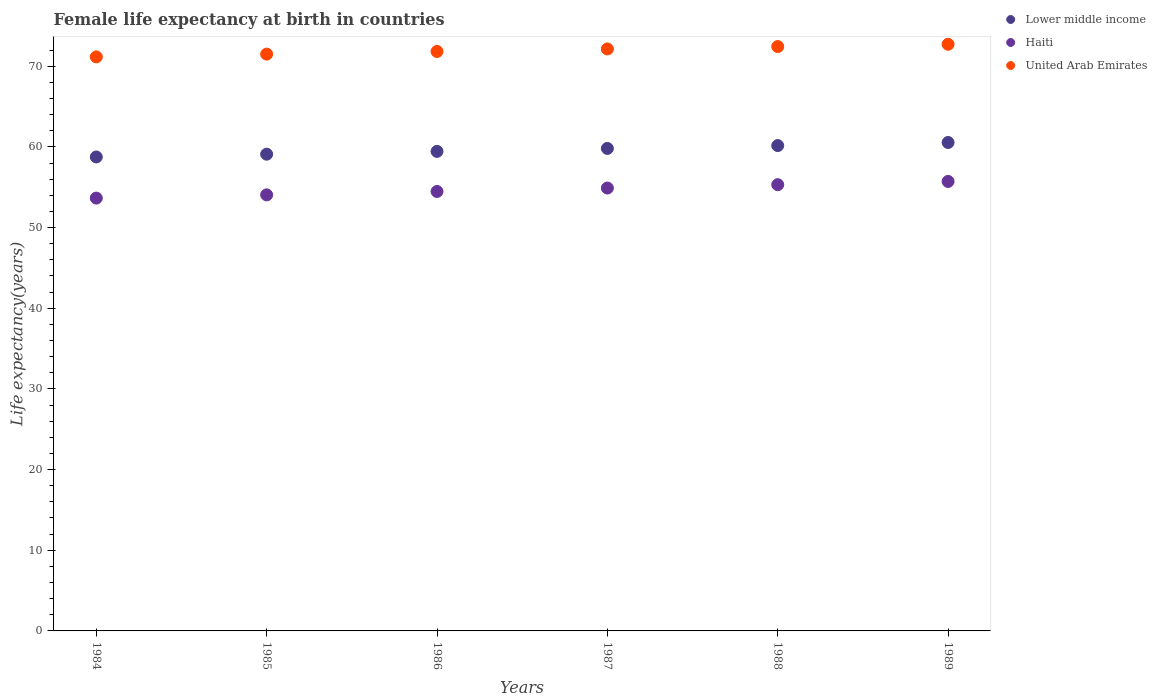What is the female life expectancy at birth in Haiti in 1987?
Provide a short and direct response. 54.9. Across all years, what is the maximum female life expectancy at birth in Lower middle income?
Your answer should be very brief. 60.55. Across all years, what is the minimum female life expectancy at birth in United Arab Emirates?
Make the answer very short. 71.16. In which year was the female life expectancy at birth in Lower middle income maximum?
Offer a very short reply. 1989. In which year was the female life expectancy at birth in Lower middle income minimum?
Provide a succinct answer. 1984. What is the total female life expectancy at birth in United Arab Emirates in the graph?
Offer a terse response. 431.77. What is the difference between the female life expectancy at birth in United Arab Emirates in 1984 and that in 1987?
Provide a succinct answer. -0.98. What is the difference between the female life expectancy at birth in Lower middle income in 1985 and the female life expectancy at birth in Haiti in 1988?
Keep it short and to the point. 3.78. What is the average female life expectancy at birth in Haiti per year?
Provide a short and direct response. 54.68. In the year 1984, what is the difference between the female life expectancy at birth in Lower middle income and female life expectancy at birth in United Arab Emirates?
Provide a succinct answer. -12.4. In how many years, is the female life expectancy at birth in Lower middle income greater than 52 years?
Provide a short and direct response. 6. What is the ratio of the female life expectancy at birth in Lower middle income in 1988 to that in 1989?
Provide a short and direct response. 0.99. Is the difference between the female life expectancy at birth in Lower middle income in 1984 and 1986 greater than the difference between the female life expectancy at birth in United Arab Emirates in 1984 and 1986?
Your response must be concise. No. What is the difference between the highest and the second highest female life expectancy at birth in Lower middle income?
Make the answer very short. 0.38. What is the difference between the highest and the lowest female life expectancy at birth in Lower middle income?
Provide a succinct answer. 1.8. Is it the case that in every year, the sum of the female life expectancy at birth in Lower middle income and female life expectancy at birth in Haiti  is greater than the female life expectancy at birth in United Arab Emirates?
Offer a very short reply. Yes. Does the female life expectancy at birth in Lower middle income monotonically increase over the years?
Make the answer very short. Yes. Are the values on the major ticks of Y-axis written in scientific E-notation?
Provide a succinct answer. No. Does the graph contain any zero values?
Offer a terse response. No. Does the graph contain grids?
Offer a terse response. No. What is the title of the graph?
Provide a short and direct response. Female life expectancy at birth in countries. Does "Middle East & North Africa (developing only)" appear as one of the legend labels in the graph?
Your response must be concise. No. What is the label or title of the Y-axis?
Make the answer very short. Life expectancy(years). What is the Life expectancy(years) in Lower middle income in 1984?
Your answer should be very brief. 58.75. What is the Life expectancy(years) in Haiti in 1984?
Provide a short and direct response. 53.65. What is the Life expectancy(years) in United Arab Emirates in 1984?
Your response must be concise. 71.16. What is the Life expectancy(years) of Lower middle income in 1985?
Give a very brief answer. 59.09. What is the Life expectancy(years) in Haiti in 1985?
Offer a very short reply. 54.05. What is the Life expectancy(years) of United Arab Emirates in 1985?
Your response must be concise. 71.5. What is the Life expectancy(years) in Lower middle income in 1986?
Your answer should be very brief. 59.44. What is the Life expectancy(years) of Haiti in 1986?
Ensure brevity in your answer.  54.47. What is the Life expectancy(years) of United Arab Emirates in 1986?
Offer a terse response. 71.83. What is the Life expectancy(years) in Lower middle income in 1987?
Your answer should be very brief. 59.81. What is the Life expectancy(years) in Haiti in 1987?
Provide a short and direct response. 54.9. What is the Life expectancy(years) of United Arab Emirates in 1987?
Your response must be concise. 72.14. What is the Life expectancy(years) of Lower middle income in 1988?
Give a very brief answer. 60.16. What is the Life expectancy(years) in Haiti in 1988?
Offer a very short reply. 55.31. What is the Life expectancy(years) of United Arab Emirates in 1988?
Make the answer very short. 72.44. What is the Life expectancy(years) in Lower middle income in 1989?
Your answer should be very brief. 60.55. What is the Life expectancy(years) of Haiti in 1989?
Your response must be concise. 55.72. What is the Life expectancy(years) in United Arab Emirates in 1989?
Offer a very short reply. 72.72. Across all years, what is the maximum Life expectancy(years) in Lower middle income?
Provide a short and direct response. 60.55. Across all years, what is the maximum Life expectancy(years) of Haiti?
Provide a short and direct response. 55.72. Across all years, what is the maximum Life expectancy(years) of United Arab Emirates?
Offer a terse response. 72.72. Across all years, what is the minimum Life expectancy(years) in Lower middle income?
Provide a succinct answer. 58.75. Across all years, what is the minimum Life expectancy(years) of Haiti?
Ensure brevity in your answer.  53.65. Across all years, what is the minimum Life expectancy(years) of United Arab Emirates?
Your answer should be very brief. 71.16. What is the total Life expectancy(years) of Lower middle income in the graph?
Offer a terse response. 357.8. What is the total Life expectancy(years) of Haiti in the graph?
Your answer should be very brief. 328.11. What is the total Life expectancy(years) of United Arab Emirates in the graph?
Provide a short and direct response. 431.77. What is the difference between the Life expectancy(years) in Lower middle income in 1984 and that in 1985?
Offer a very short reply. -0.34. What is the difference between the Life expectancy(years) of Haiti in 1984 and that in 1985?
Give a very brief answer. -0.4. What is the difference between the Life expectancy(years) in United Arab Emirates in 1984 and that in 1985?
Your answer should be very brief. -0.34. What is the difference between the Life expectancy(years) of Lower middle income in 1984 and that in 1986?
Your answer should be compact. -0.69. What is the difference between the Life expectancy(years) of Haiti in 1984 and that in 1986?
Give a very brief answer. -0.82. What is the difference between the Life expectancy(years) of United Arab Emirates in 1984 and that in 1986?
Provide a short and direct response. -0.67. What is the difference between the Life expectancy(years) of Lower middle income in 1984 and that in 1987?
Offer a terse response. -1.06. What is the difference between the Life expectancy(years) of Haiti in 1984 and that in 1987?
Offer a terse response. -1.25. What is the difference between the Life expectancy(years) in United Arab Emirates in 1984 and that in 1987?
Give a very brief answer. -0.98. What is the difference between the Life expectancy(years) in Lower middle income in 1984 and that in 1988?
Your response must be concise. -1.41. What is the difference between the Life expectancy(years) in Haiti in 1984 and that in 1988?
Your answer should be very brief. -1.67. What is the difference between the Life expectancy(years) in United Arab Emirates in 1984 and that in 1988?
Your response must be concise. -1.28. What is the difference between the Life expectancy(years) of Lower middle income in 1984 and that in 1989?
Make the answer very short. -1.8. What is the difference between the Life expectancy(years) in Haiti in 1984 and that in 1989?
Offer a terse response. -2.07. What is the difference between the Life expectancy(years) of United Arab Emirates in 1984 and that in 1989?
Give a very brief answer. -1.56. What is the difference between the Life expectancy(years) of Lower middle income in 1985 and that in 1986?
Make the answer very short. -0.35. What is the difference between the Life expectancy(years) of Haiti in 1985 and that in 1986?
Offer a very short reply. -0.42. What is the difference between the Life expectancy(years) in United Arab Emirates in 1985 and that in 1986?
Provide a succinct answer. -0.33. What is the difference between the Life expectancy(years) in Lower middle income in 1985 and that in 1987?
Provide a short and direct response. -0.71. What is the difference between the Life expectancy(years) of Haiti in 1985 and that in 1987?
Provide a succinct answer. -0.84. What is the difference between the Life expectancy(years) in United Arab Emirates in 1985 and that in 1987?
Your answer should be compact. -0.64. What is the difference between the Life expectancy(years) in Lower middle income in 1985 and that in 1988?
Make the answer very short. -1.07. What is the difference between the Life expectancy(years) of Haiti in 1985 and that in 1988?
Your answer should be compact. -1.26. What is the difference between the Life expectancy(years) in United Arab Emirates in 1985 and that in 1988?
Your answer should be very brief. -0.94. What is the difference between the Life expectancy(years) in Lower middle income in 1985 and that in 1989?
Ensure brevity in your answer.  -1.45. What is the difference between the Life expectancy(years) of Haiti in 1985 and that in 1989?
Offer a terse response. -1.67. What is the difference between the Life expectancy(years) of United Arab Emirates in 1985 and that in 1989?
Ensure brevity in your answer.  -1.22. What is the difference between the Life expectancy(years) in Lower middle income in 1986 and that in 1987?
Keep it short and to the point. -0.37. What is the difference between the Life expectancy(years) of Haiti in 1986 and that in 1987?
Provide a short and direct response. -0.42. What is the difference between the Life expectancy(years) of United Arab Emirates in 1986 and that in 1987?
Your response must be concise. -0.31. What is the difference between the Life expectancy(years) of Lower middle income in 1986 and that in 1988?
Make the answer very short. -0.72. What is the difference between the Life expectancy(years) of Haiti in 1986 and that in 1988?
Make the answer very short. -0.84. What is the difference between the Life expectancy(years) of United Arab Emirates in 1986 and that in 1988?
Provide a succinct answer. -0.61. What is the difference between the Life expectancy(years) of Lower middle income in 1986 and that in 1989?
Make the answer very short. -1.1. What is the difference between the Life expectancy(years) of Haiti in 1986 and that in 1989?
Ensure brevity in your answer.  -1.24. What is the difference between the Life expectancy(years) of United Arab Emirates in 1986 and that in 1989?
Offer a terse response. -0.89. What is the difference between the Life expectancy(years) of Lower middle income in 1987 and that in 1988?
Your answer should be very brief. -0.35. What is the difference between the Life expectancy(years) in Haiti in 1987 and that in 1988?
Your answer should be very brief. -0.42. What is the difference between the Life expectancy(years) of United Arab Emirates in 1987 and that in 1988?
Provide a succinct answer. -0.3. What is the difference between the Life expectancy(years) in Lower middle income in 1987 and that in 1989?
Your answer should be compact. -0.74. What is the difference between the Life expectancy(years) of Haiti in 1987 and that in 1989?
Your answer should be very brief. -0.82. What is the difference between the Life expectancy(years) in United Arab Emirates in 1987 and that in 1989?
Your response must be concise. -0.58. What is the difference between the Life expectancy(years) of Lower middle income in 1988 and that in 1989?
Your answer should be compact. -0.38. What is the difference between the Life expectancy(years) in Haiti in 1988 and that in 1989?
Give a very brief answer. -0.4. What is the difference between the Life expectancy(years) in United Arab Emirates in 1988 and that in 1989?
Keep it short and to the point. -0.28. What is the difference between the Life expectancy(years) of Lower middle income in 1984 and the Life expectancy(years) of Haiti in 1985?
Make the answer very short. 4.7. What is the difference between the Life expectancy(years) in Lower middle income in 1984 and the Life expectancy(years) in United Arab Emirates in 1985?
Your response must be concise. -12.75. What is the difference between the Life expectancy(years) of Haiti in 1984 and the Life expectancy(years) of United Arab Emirates in 1985?
Your answer should be compact. -17.85. What is the difference between the Life expectancy(years) of Lower middle income in 1984 and the Life expectancy(years) of Haiti in 1986?
Keep it short and to the point. 4.28. What is the difference between the Life expectancy(years) in Lower middle income in 1984 and the Life expectancy(years) in United Arab Emirates in 1986?
Provide a succinct answer. -13.08. What is the difference between the Life expectancy(years) of Haiti in 1984 and the Life expectancy(years) of United Arab Emirates in 1986?
Your response must be concise. -18.18. What is the difference between the Life expectancy(years) of Lower middle income in 1984 and the Life expectancy(years) of Haiti in 1987?
Provide a succinct answer. 3.85. What is the difference between the Life expectancy(years) in Lower middle income in 1984 and the Life expectancy(years) in United Arab Emirates in 1987?
Keep it short and to the point. -13.39. What is the difference between the Life expectancy(years) of Haiti in 1984 and the Life expectancy(years) of United Arab Emirates in 1987?
Give a very brief answer. -18.49. What is the difference between the Life expectancy(years) of Lower middle income in 1984 and the Life expectancy(years) of Haiti in 1988?
Give a very brief answer. 3.44. What is the difference between the Life expectancy(years) of Lower middle income in 1984 and the Life expectancy(years) of United Arab Emirates in 1988?
Your answer should be very brief. -13.68. What is the difference between the Life expectancy(years) of Haiti in 1984 and the Life expectancy(years) of United Arab Emirates in 1988?
Your answer should be very brief. -18.79. What is the difference between the Life expectancy(years) in Lower middle income in 1984 and the Life expectancy(years) in Haiti in 1989?
Offer a very short reply. 3.03. What is the difference between the Life expectancy(years) of Lower middle income in 1984 and the Life expectancy(years) of United Arab Emirates in 1989?
Your response must be concise. -13.97. What is the difference between the Life expectancy(years) of Haiti in 1984 and the Life expectancy(years) of United Arab Emirates in 1989?
Your answer should be compact. -19.07. What is the difference between the Life expectancy(years) of Lower middle income in 1985 and the Life expectancy(years) of Haiti in 1986?
Keep it short and to the point. 4.62. What is the difference between the Life expectancy(years) of Lower middle income in 1985 and the Life expectancy(years) of United Arab Emirates in 1986?
Your answer should be compact. -12.73. What is the difference between the Life expectancy(years) in Haiti in 1985 and the Life expectancy(years) in United Arab Emirates in 1986?
Your answer should be compact. -17.77. What is the difference between the Life expectancy(years) of Lower middle income in 1985 and the Life expectancy(years) of Haiti in 1987?
Provide a short and direct response. 4.2. What is the difference between the Life expectancy(years) in Lower middle income in 1985 and the Life expectancy(years) in United Arab Emirates in 1987?
Ensure brevity in your answer.  -13.04. What is the difference between the Life expectancy(years) in Haiti in 1985 and the Life expectancy(years) in United Arab Emirates in 1987?
Offer a terse response. -18.09. What is the difference between the Life expectancy(years) of Lower middle income in 1985 and the Life expectancy(years) of Haiti in 1988?
Provide a short and direct response. 3.78. What is the difference between the Life expectancy(years) in Lower middle income in 1985 and the Life expectancy(years) in United Arab Emirates in 1988?
Give a very brief answer. -13.34. What is the difference between the Life expectancy(years) in Haiti in 1985 and the Life expectancy(years) in United Arab Emirates in 1988?
Your response must be concise. -18.38. What is the difference between the Life expectancy(years) in Lower middle income in 1985 and the Life expectancy(years) in Haiti in 1989?
Your response must be concise. 3.38. What is the difference between the Life expectancy(years) of Lower middle income in 1985 and the Life expectancy(years) of United Arab Emirates in 1989?
Provide a succinct answer. -13.63. What is the difference between the Life expectancy(years) in Haiti in 1985 and the Life expectancy(years) in United Arab Emirates in 1989?
Offer a very short reply. -18.67. What is the difference between the Life expectancy(years) in Lower middle income in 1986 and the Life expectancy(years) in Haiti in 1987?
Ensure brevity in your answer.  4.54. What is the difference between the Life expectancy(years) in Lower middle income in 1986 and the Life expectancy(years) in United Arab Emirates in 1987?
Provide a succinct answer. -12.7. What is the difference between the Life expectancy(years) in Haiti in 1986 and the Life expectancy(years) in United Arab Emirates in 1987?
Your answer should be compact. -17.66. What is the difference between the Life expectancy(years) in Lower middle income in 1986 and the Life expectancy(years) in Haiti in 1988?
Make the answer very short. 4.13. What is the difference between the Life expectancy(years) of Lower middle income in 1986 and the Life expectancy(years) of United Arab Emirates in 1988?
Give a very brief answer. -12.99. What is the difference between the Life expectancy(years) of Haiti in 1986 and the Life expectancy(years) of United Arab Emirates in 1988?
Your answer should be compact. -17.96. What is the difference between the Life expectancy(years) of Lower middle income in 1986 and the Life expectancy(years) of Haiti in 1989?
Give a very brief answer. 3.72. What is the difference between the Life expectancy(years) of Lower middle income in 1986 and the Life expectancy(years) of United Arab Emirates in 1989?
Give a very brief answer. -13.28. What is the difference between the Life expectancy(years) of Haiti in 1986 and the Life expectancy(years) of United Arab Emirates in 1989?
Your response must be concise. -18.25. What is the difference between the Life expectancy(years) of Lower middle income in 1987 and the Life expectancy(years) of Haiti in 1988?
Give a very brief answer. 4.49. What is the difference between the Life expectancy(years) in Lower middle income in 1987 and the Life expectancy(years) in United Arab Emirates in 1988?
Offer a terse response. -12.63. What is the difference between the Life expectancy(years) of Haiti in 1987 and the Life expectancy(years) of United Arab Emirates in 1988?
Your answer should be very brief. -17.54. What is the difference between the Life expectancy(years) in Lower middle income in 1987 and the Life expectancy(years) in Haiti in 1989?
Provide a succinct answer. 4.09. What is the difference between the Life expectancy(years) of Lower middle income in 1987 and the Life expectancy(years) of United Arab Emirates in 1989?
Your response must be concise. -12.91. What is the difference between the Life expectancy(years) in Haiti in 1987 and the Life expectancy(years) in United Arab Emirates in 1989?
Make the answer very short. -17.82. What is the difference between the Life expectancy(years) of Lower middle income in 1988 and the Life expectancy(years) of Haiti in 1989?
Ensure brevity in your answer.  4.44. What is the difference between the Life expectancy(years) in Lower middle income in 1988 and the Life expectancy(years) in United Arab Emirates in 1989?
Provide a short and direct response. -12.56. What is the difference between the Life expectancy(years) of Haiti in 1988 and the Life expectancy(years) of United Arab Emirates in 1989?
Provide a short and direct response. -17.41. What is the average Life expectancy(years) in Lower middle income per year?
Offer a very short reply. 59.63. What is the average Life expectancy(years) in Haiti per year?
Provide a succinct answer. 54.68. What is the average Life expectancy(years) of United Arab Emirates per year?
Offer a terse response. 71.96. In the year 1984, what is the difference between the Life expectancy(years) of Lower middle income and Life expectancy(years) of Haiti?
Offer a very short reply. 5.1. In the year 1984, what is the difference between the Life expectancy(years) of Lower middle income and Life expectancy(years) of United Arab Emirates?
Offer a terse response. -12.4. In the year 1984, what is the difference between the Life expectancy(years) in Haiti and Life expectancy(years) in United Arab Emirates?
Give a very brief answer. -17.5. In the year 1985, what is the difference between the Life expectancy(years) in Lower middle income and Life expectancy(years) in Haiti?
Provide a succinct answer. 5.04. In the year 1985, what is the difference between the Life expectancy(years) of Lower middle income and Life expectancy(years) of United Arab Emirates?
Offer a very short reply. -12.41. In the year 1985, what is the difference between the Life expectancy(years) in Haiti and Life expectancy(years) in United Arab Emirates?
Provide a short and direct response. -17.45. In the year 1986, what is the difference between the Life expectancy(years) of Lower middle income and Life expectancy(years) of Haiti?
Give a very brief answer. 4.97. In the year 1986, what is the difference between the Life expectancy(years) of Lower middle income and Life expectancy(years) of United Arab Emirates?
Keep it short and to the point. -12.39. In the year 1986, what is the difference between the Life expectancy(years) in Haiti and Life expectancy(years) in United Arab Emirates?
Your answer should be very brief. -17.35. In the year 1987, what is the difference between the Life expectancy(years) in Lower middle income and Life expectancy(years) in Haiti?
Provide a short and direct response. 4.91. In the year 1987, what is the difference between the Life expectancy(years) of Lower middle income and Life expectancy(years) of United Arab Emirates?
Your answer should be very brief. -12.33. In the year 1987, what is the difference between the Life expectancy(years) of Haiti and Life expectancy(years) of United Arab Emirates?
Provide a short and direct response. -17.24. In the year 1988, what is the difference between the Life expectancy(years) of Lower middle income and Life expectancy(years) of Haiti?
Your response must be concise. 4.85. In the year 1988, what is the difference between the Life expectancy(years) in Lower middle income and Life expectancy(years) in United Arab Emirates?
Offer a very short reply. -12.27. In the year 1988, what is the difference between the Life expectancy(years) of Haiti and Life expectancy(years) of United Arab Emirates?
Give a very brief answer. -17.12. In the year 1989, what is the difference between the Life expectancy(years) of Lower middle income and Life expectancy(years) of Haiti?
Your response must be concise. 4.83. In the year 1989, what is the difference between the Life expectancy(years) in Lower middle income and Life expectancy(years) in United Arab Emirates?
Ensure brevity in your answer.  -12.17. In the year 1989, what is the difference between the Life expectancy(years) of Haiti and Life expectancy(years) of United Arab Emirates?
Provide a succinct answer. -17. What is the ratio of the Life expectancy(years) in Haiti in 1984 to that in 1985?
Give a very brief answer. 0.99. What is the ratio of the Life expectancy(years) in Lower middle income in 1984 to that in 1986?
Provide a short and direct response. 0.99. What is the ratio of the Life expectancy(years) in Haiti in 1984 to that in 1986?
Provide a succinct answer. 0.98. What is the ratio of the Life expectancy(years) of United Arab Emirates in 1984 to that in 1986?
Your answer should be very brief. 0.99. What is the ratio of the Life expectancy(years) in Lower middle income in 1984 to that in 1987?
Make the answer very short. 0.98. What is the ratio of the Life expectancy(years) of Haiti in 1984 to that in 1987?
Keep it short and to the point. 0.98. What is the ratio of the Life expectancy(years) of United Arab Emirates in 1984 to that in 1987?
Give a very brief answer. 0.99. What is the ratio of the Life expectancy(years) in Lower middle income in 1984 to that in 1988?
Keep it short and to the point. 0.98. What is the ratio of the Life expectancy(years) of Haiti in 1984 to that in 1988?
Provide a succinct answer. 0.97. What is the ratio of the Life expectancy(years) of United Arab Emirates in 1984 to that in 1988?
Ensure brevity in your answer.  0.98. What is the ratio of the Life expectancy(years) of Lower middle income in 1984 to that in 1989?
Make the answer very short. 0.97. What is the ratio of the Life expectancy(years) in Haiti in 1984 to that in 1989?
Provide a succinct answer. 0.96. What is the ratio of the Life expectancy(years) of United Arab Emirates in 1984 to that in 1989?
Offer a terse response. 0.98. What is the ratio of the Life expectancy(years) of Lower middle income in 1985 to that in 1986?
Offer a terse response. 0.99. What is the ratio of the Life expectancy(years) of United Arab Emirates in 1985 to that in 1986?
Your answer should be very brief. 1. What is the ratio of the Life expectancy(years) of Haiti in 1985 to that in 1987?
Ensure brevity in your answer.  0.98. What is the ratio of the Life expectancy(years) of Lower middle income in 1985 to that in 1988?
Your answer should be very brief. 0.98. What is the ratio of the Life expectancy(years) of Haiti in 1985 to that in 1988?
Ensure brevity in your answer.  0.98. What is the ratio of the Life expectancy(years) of United Arab Emirates in 1985 to that in 1988?
Your answer should be very brief. 0.99. What is the ratio of the Life expectancy(years) in Haiti in 1985 to that in 1989?
Give a very brief answer. 0.97. What is the ratio of the Life expectancy(years) in United Arab Emirates in 1985 to that in 1989?
Provide a short and direct response. 0.98. What is the ratio of the Life expectancy(years) of United Arab Emirates in 1986 to that in 1987?
Provide a short and direct response. 1. What is the ratio of the Life expectancy(years) in Lower middle income in 1986 to that in 1988?
Keep it short and to the point. 0.99. What is the ratio of the Life expectancy(years) of United Arab Emirates in 1986 to that in 1988?
Your response must be concise. 0.99. What is the ratio of the Life expectancy(years) of Lower middle income in 1986 to that in 1989?
Ensure brevity in your answer.  0.98. What is the ratio of the Life expectancy(years) of Haiti in 1986 to that in 1989?
Offer a very short reply. 0.98. What is the ratio of the Life expectancy(years) in Lower middle income in 1987 to that in 1988?
Provide a short and direct response. 0.99. What is the ratio of the Life expectancy(years) of Haiti in 1987 to that in 1988?
Your answer should be compact. 0.99. What is the ratio of the Life expectancy(years) of United Arab Emirates in 1987 to that in 1988?
Your response must be concise. 1. What is the ratio of the Life expectancy(years) of Lower middle income in 1987 to that in 1989?
Your answer should be very brief. 0.99. What is the ratio of the Life expectancy(years) of Haiti in 1987 to that in 1989?
Your response must be concise. 0.99. What is the ratio of the Life expectancy(years) in Haiti in 1988 to that in 1989?
Your answer should be very brief. 0.99. What is the ratio of the Life expectancy(years) of United Arab Emirates in 1988 to that in 1989?
Offer a terse response. 1. What is the difference between the highest and the second highest Life expectancy(years) of Lower middle income?
Provide a succinct answer. 0.38. What is the difference between the highest and the second highest Life expectancy(years) of Haiti?
Provide a succinct answer. 0.4. What is the difference between the highest and the second highest Life expectancy(years) in United Arab Emirates?
Offer a very short reply. 0.28. What is the difference between the highest and the lowest Life expectancy(years) in Lower middle income?
Make the answer very short. 1.8. What is the difference between the highest and the lowest Life expectancy(years) in Haiti?
Your answer should be very brief. 2.07. What is the difference between the highest and the lowest Life expectancy(years) of United Arab Emirates?
Your answer should be compact. 1.56. 